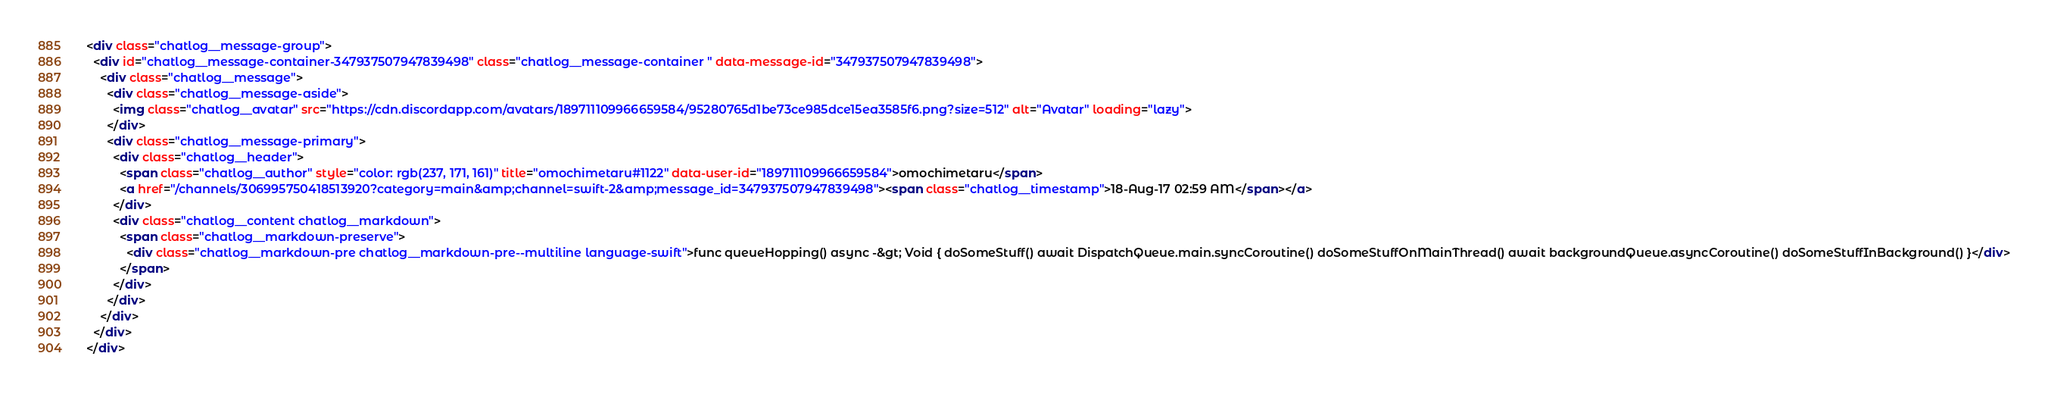<code> <loc_0><loc_0><loc_500><loc_500><_HTML_><div class="chatlog__message-group">
  <div id="chatlog__message-container-347937507947839498" class="chatlog__message-container " data-message-id="347937507947839498">
    <div class="chatlog__message">
      <div class="chatlog__message-aside">
        <img class="chatlog__avatar" src="https://cdn.discordapp.com/avatars/189711109966659584/95280765d1be73ce985dce15ea3585f6.png?size=512" alt="Avatar" loading="lazy">
      </div>
      <div class="chatlog__message-primary">
        <div class="chatlog__header">
          <span class="chatlog__author" style="color: rgb(237, 171, 161)" title="omochimetaru#1122" data-user-id="189711109966659584">omochimetaru</span>
          <a href="/channels/306995750418513920?category=main&amp;channel=swift-2&amp;message_id=347937507947839498"><span class="chatlog__timestamp">18-Aug-17 02:59 AM</span></a>
        </div>
        <div class="chatlog__content chatlog__markdown">
          <span class="chatlog__markdown-preserve">
            <div class="chatlog__markdown-pre chatlog__markdown-pre--multiline language-swift">func queueHopping() async -&gt; Void { doSomeStuff() await DispatchQueue.main.syncCoroutine() doSomeStuffOnMainThread() await backgroundQueue.asyncCoroutine() doSomeStuffInBackground() }</div>
          </span>
        </div>
      </div>
    </div>
  </div>
</div></code> 